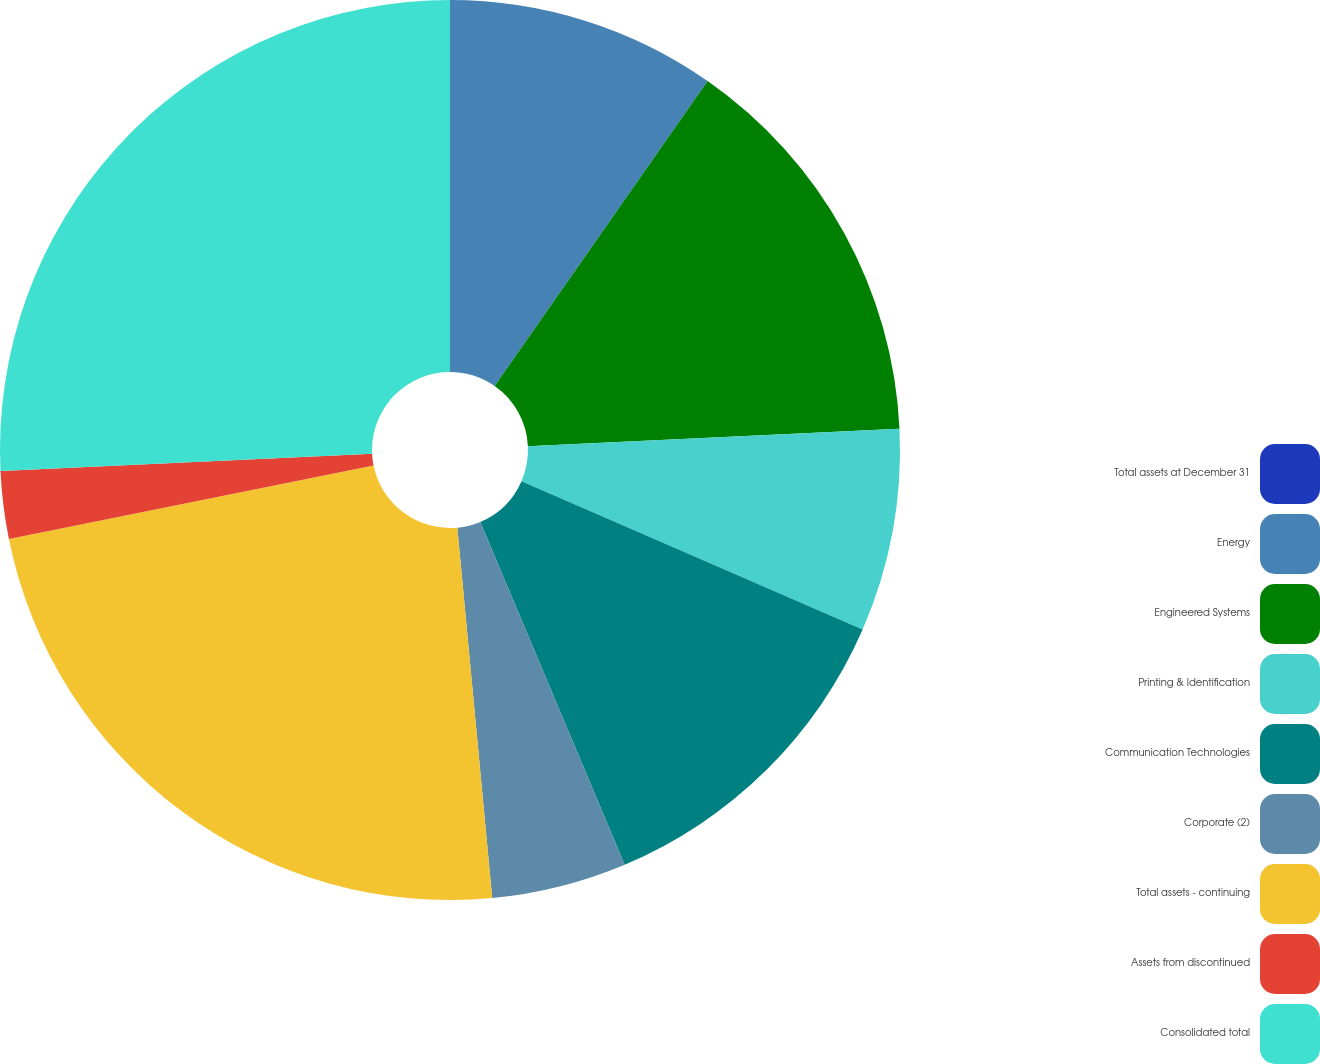Convert chart. <chart><loc_0><loc_0><loc_500><loc_500><pie_chart><fcel>Total assets at December 31<fcel>Energy<fcel>Engineered Systems<fcel>Printing & Identification<fcel>Communication Technologies<fcel>Corporate (2)<fcel>Total assets - continuing<fcel>Assets from discontinued<fcel>Consolidated total<nl><fcel>0.0%<fcel>9.7%<fcel>14.55%<fcel>7.28%<fcel>12.12%<fcel>4.85%<fcel>23.32%<fcel>2.43%<fcel>25.74%<nl></chart> 